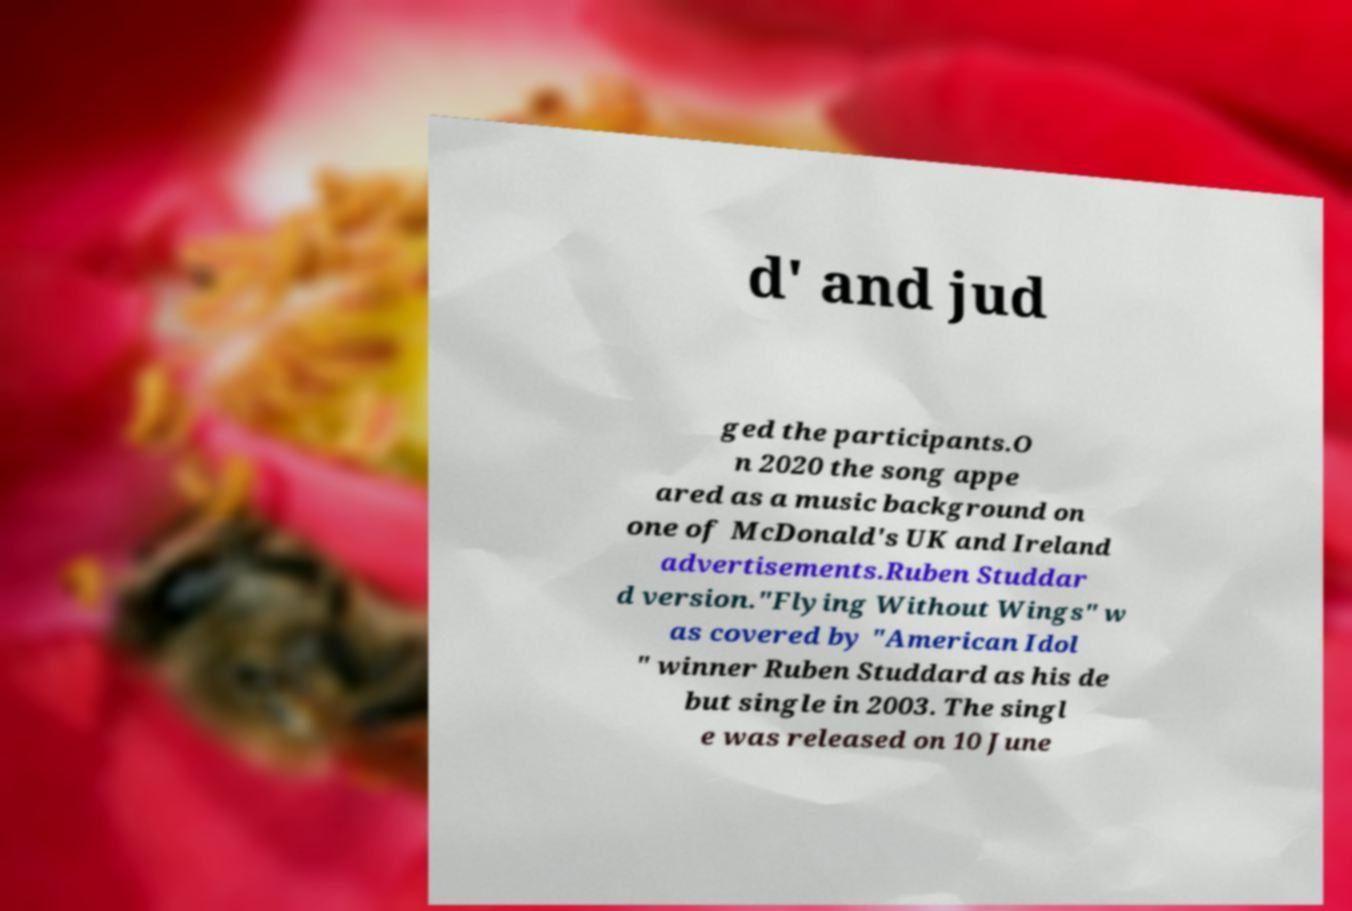For documentation purposes, I need the text within this image transcribed. Could you provide that? d' and jud ged the participants.O n 2020 the song appe ared as a music background on one of McDonald's UK and Ireland advertisements.Ruben Studdar d version."Flying Without Wings" w as covered by "American Idol " winner Ruben Studdard as his de but single in 2003. The singl e was released on 10 June 